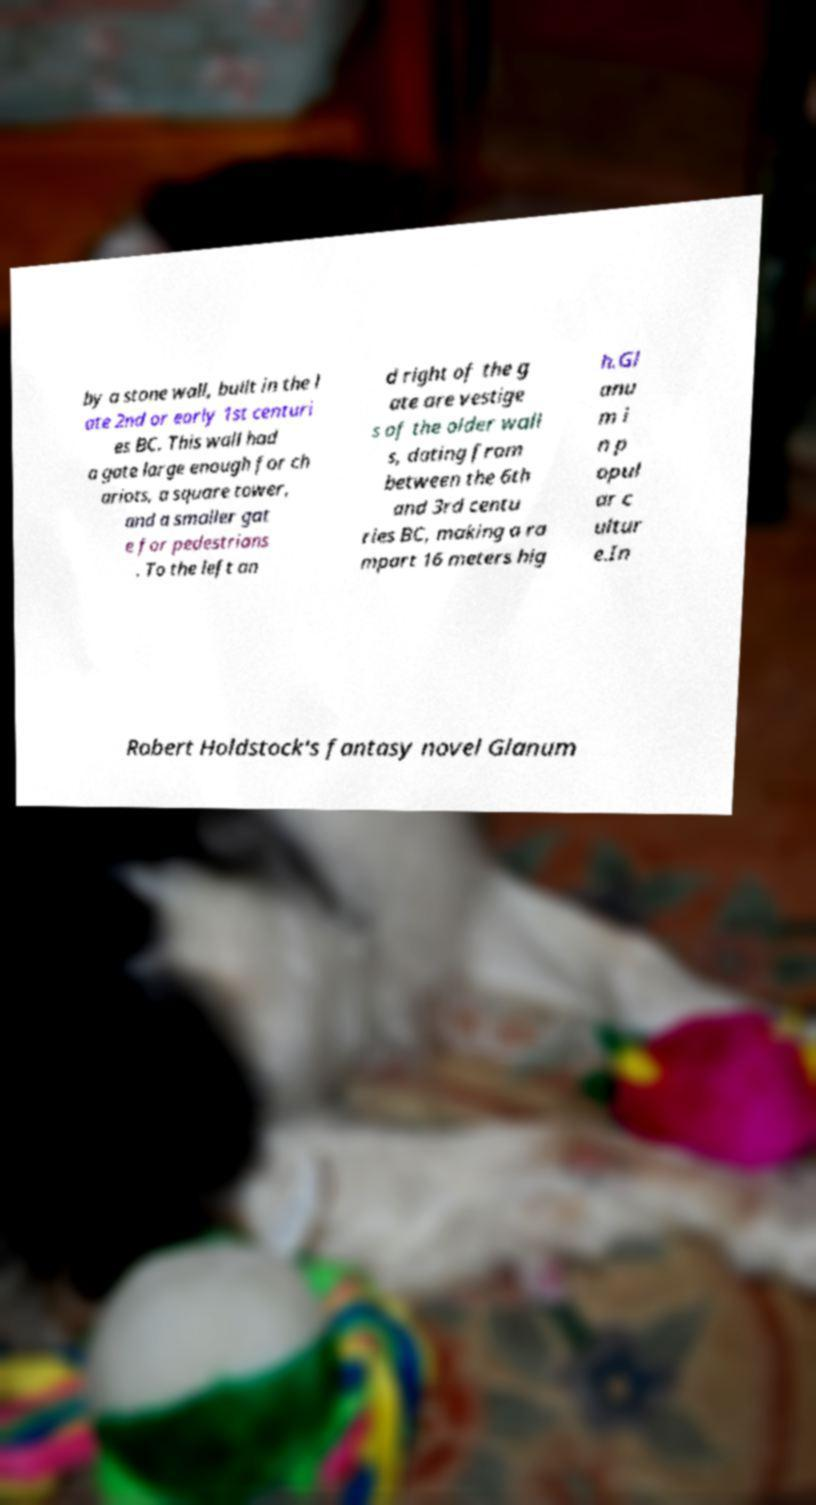For documentation purposes, I need the text within this image transcribed. Could you provide that? by a stone wall, built in the l ate 2nd or early 1st centuri es BC. This wall had a gate large enough for ch ariots, a square tower, and a smaller gat e for pedestrians . To the left an d right of the g ate are vestige s of the older wall s, dating from between the 6th and 3rd centu ries BC, making a ra mpart 16 meters hig h.Gl anu m i n p opul ar c ultur e.In Robert Holdstock's fantasy novel Glanum 